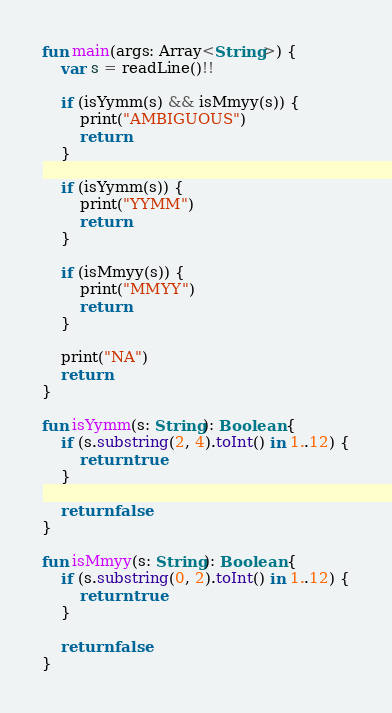<code> <loc_0><loc_0><loc_500><loc_500><_Kotlin_>fun main(args: Array<String>) {
    var s = readLine()!!

    if (isYymm(s) && isMmyy(s)) {
        print("AMBIGUOUS")
        return
    }

    if (isYymm(s)) {
        print("YYMM")
        return
    }

    if (isMmyy(s)) {
        print("MMYY")
        return
    }

    print("NA")
    return
}

fun isYymm(s: String): Boolean {
    if (s.substring(2, 4).toInt() in 1..12) {
        return true
    }

    return false
}

fun isMmyy(s: String): Boolean {
    if (s.substring(0, 2).toInt() in 1..12) {
        return true
    }

    return false
}</code> 